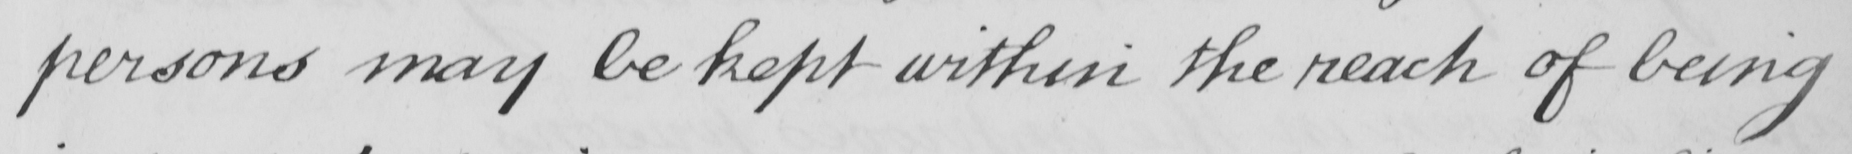What text is written in this handwritten line? persons may be kept within the reach of being 